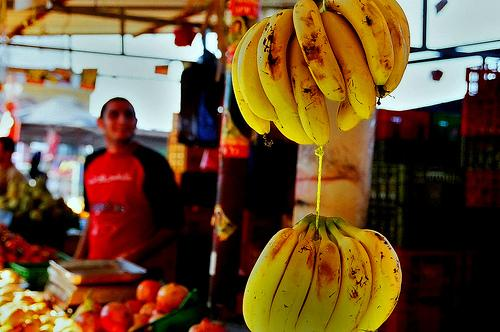What can hanging the bananas avoid? black spots 